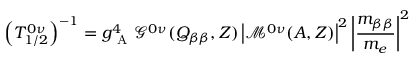<formula> <loc_0><loc_0><loc_500><loc_500>\left ( T _ { 1 / 2 } ^ { 0 \nu } \right ) ^ { - 1 } = g _ { A } ^ { 4 } \mathcal { G } ^ { 0 \nu } ( Q _ { \beta \beta } , Z ) \left | \mathcal { M } ^ { 0 \nu } ( A , Z ) \right | ^ { 2 } \left | \frac { m _ { \beta \beta } } { m _ { e } } \right | ^ { 2 }</formula> 